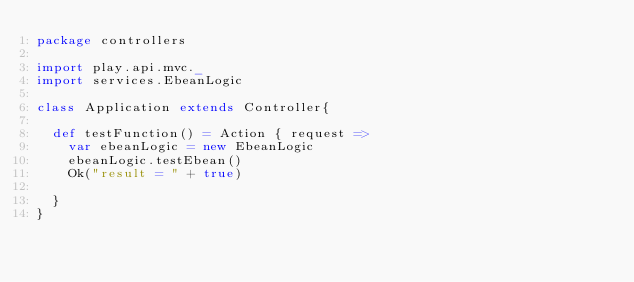Convert code to text. <code><loc_0><loc_0><loc_500><loc_500><_Scala_>package controllers

import play.api.mvc._
import services.EbeanLogic

class Application extends Controller{

  def testFunction() = Action { request =>
    var ebeanLogic = new EbeanLogic
    ebeanLogic.testEbean()
    Ok("result = " + true)

  }
}</code> 